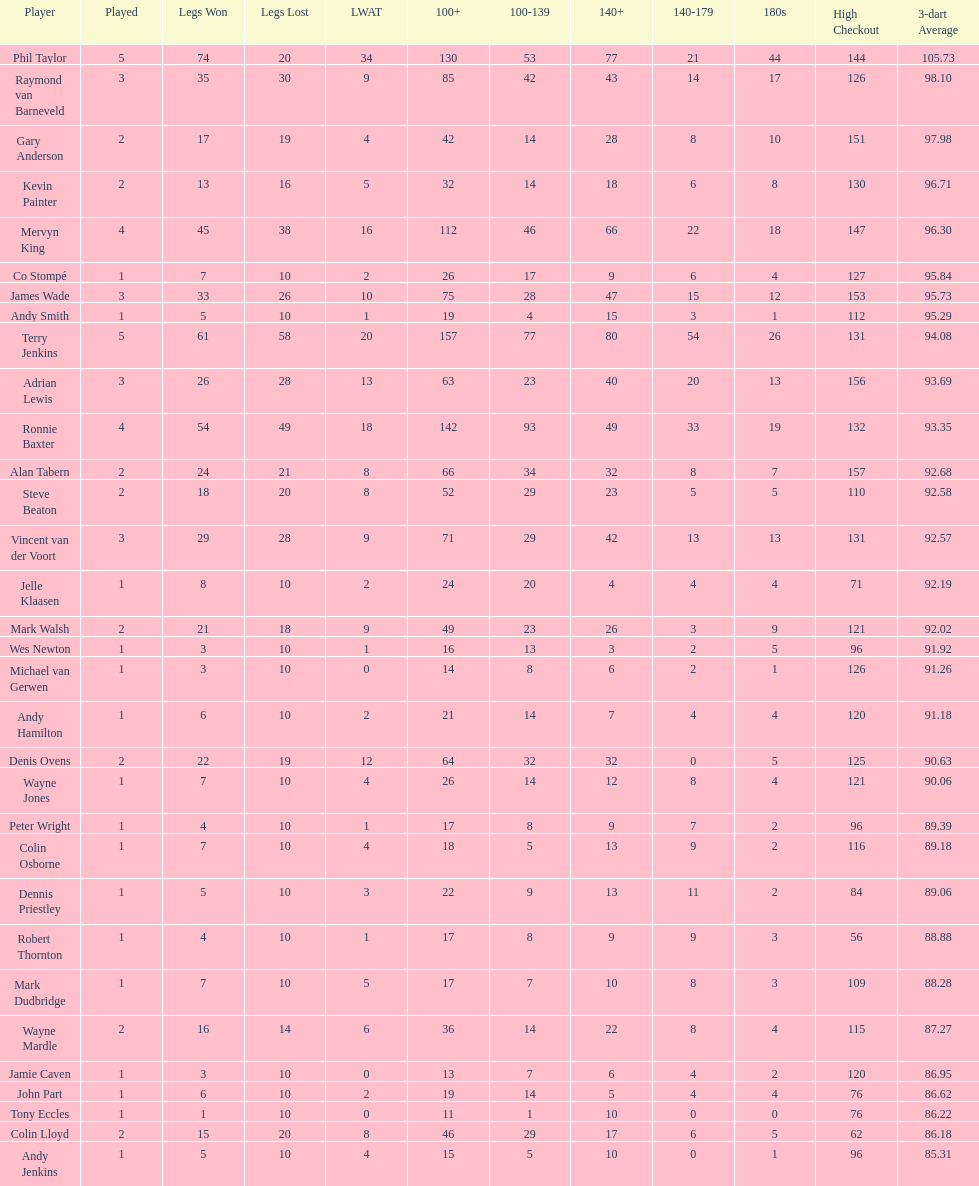Can you parse all the data within this table? {'header': ['Player', 'Played', 'Legs Won', 'Legs Lost', 'LWAT', '100+', '100-139', '140+', '140-179', '180s', 'High Checkout', '3-dart Average'], 'rows': [['Phil Taylor', '5', '74', '20', '34', '130', '53', '77', '21', '44', '144', '105.73'], ['Raymond van Barneveld', '3', '35', '30', '9', '85', '42', '43', '14', '17', '126', '98.10'], ['Gary Anderson', '2', '17', '19', '4', '42', '14', '28', '8', '10', '151', '97.98'], ['Kevin Painter', '2', '13', '16', '5', '32', '14', '18', '6', '8', '130', '96.71'], ['Mervyn King', '4', '45', '38', '16', '112', '46', '66', '22', '18', '147', '96.30'], ['Co Stompé', '1', '7', '10', '2', '26', '17', '9', '6', '4', '127', '95.84'], ['James Wade', '3', '33', '26', '10', '75', '28', '47', '15', '12', '153', '95.73'], ['Andy Smith', '1', '5', '10', '1', '19', '4', '15', '3', '1', '112', '95.29'], ['Terry Jenkins', '5', '61', '58', '20', '157', '77', '80', '54', '26', '131', '94.08'], ['Adrian Lewis', '3', '26', '28', '13', '63', '23', '40', '20', '13', '156', '93.69'], ['Ronnie Baxter', '4', '54', '49', '18', '142', '93', '49', '33', '19', '132', '93.35'], ['Alan Tabern', '2', '24', '21', '8', '66', '34', '32', '8', '7', '157', '92.68'], ['Steve Beaton', '2', '18', '20', '8', '52', '29', '23', '5', '5', '110', '92.58'], ['Vincent van der Voort', '3', '29', '28', '9', '71', '29', '42', '13', '13', '131', '92.57'], ['Jelle Klaasen', '1', '8', '10', '2', '24', '20', '4', '4', '4', '71', '92.19'], ['Mark Walsh', '2', '21', '18', '9', '49', '23', '26', '3', '9', '121', '92.02'], ['Wes Newton', '1', '3', '10', '1', '16', '13', '3', '2', '5', '96', '91.92'], ['Michael van Gerwen', '1', '3', '10', '0', '14', '8', '6', '2', '1', '126', '91.26'], ['Andy Hamilton', '1', '6', '10', '2', '21', '14', '7', '4', '4', '120', '91.18'], ['Denis Ovens', '2', '22', '19', '12', '64', '32', '32', '0', '5', '125', '90.63'], ['Wayne Jones', '1', '7', '10', '4', '26', '14', '12', '8', '4', '121', '90.06'], ['Peter Wright', '1', '4', '10', '1', '17', '8', '9', '7', '2', '96', '89.39'], ['Colin Osborne', '1', '7', '10', '4', '18', '5', '13', '9', '2', '116', '89.18'], ['Dennis Priestley', '1', '5', '10', '3', '22', '9', '13', '11', '2', '84', '89.06'], ['Robert Thornton', '1', '4', '10', '1', '17', '8', '9', '9', '3', '56', '88.88'], ['Mark Dudbridge', '1', '7', '10', '5', '17', '7', '10', '8', '3', '109', '88.28'], ['Wayne Mardle', '2', '16', '14', '6', '36', '14', '22', '8', '4', '115', '87.27'], ['Jamie Caven', '1', '3', '10', '0', '13', '7', '6', '4', '2', '120', '86.95'], ['John Part', '1', '6', '10', '2', '19', '14', '5', '4', '4', '76', '86.62'], ['Tony Eccles', '1', '1', '10', '0', '11', '1', '10', '0', '0', '76', '86.22'], ['Colin Lloyd', '2', '15', '20', '8', '46', '29', '17', '6', '5', '62', '86.18'], ['Andy Jenkins', '1', '5', '10', '4', '15', '5', '10', '0', '1', '96', '85.31']]} Which player has his high checkout as 116? Colin Osborne. 